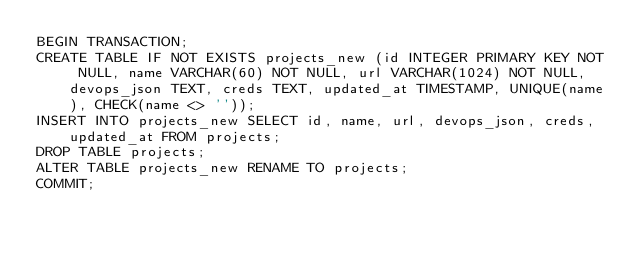<code> <loc_0><loc_0><loc_500><loc_500><_SQL_>BEGIN TRANSACTION;
CREATE TABLE IF NOT EXISTS projects_new (id INTEGER PRIMARY KEY NOT NULL, name VARCHAR(60) NOT NULL, url VARCHAR(1024) NOT NULL, devops_json TEXT, creds TEXT, updated_at TIMESTAMP, UNIQUE(name), CHECK(name <> ''));
INSERT INTO projects_new SELECT id, name, url, devops_json, creds, updated_at FROM projects;
DROP TABLE projects;
ALTER TABLE projects_new RENAME TO projects;
COMMIT;
</code> 